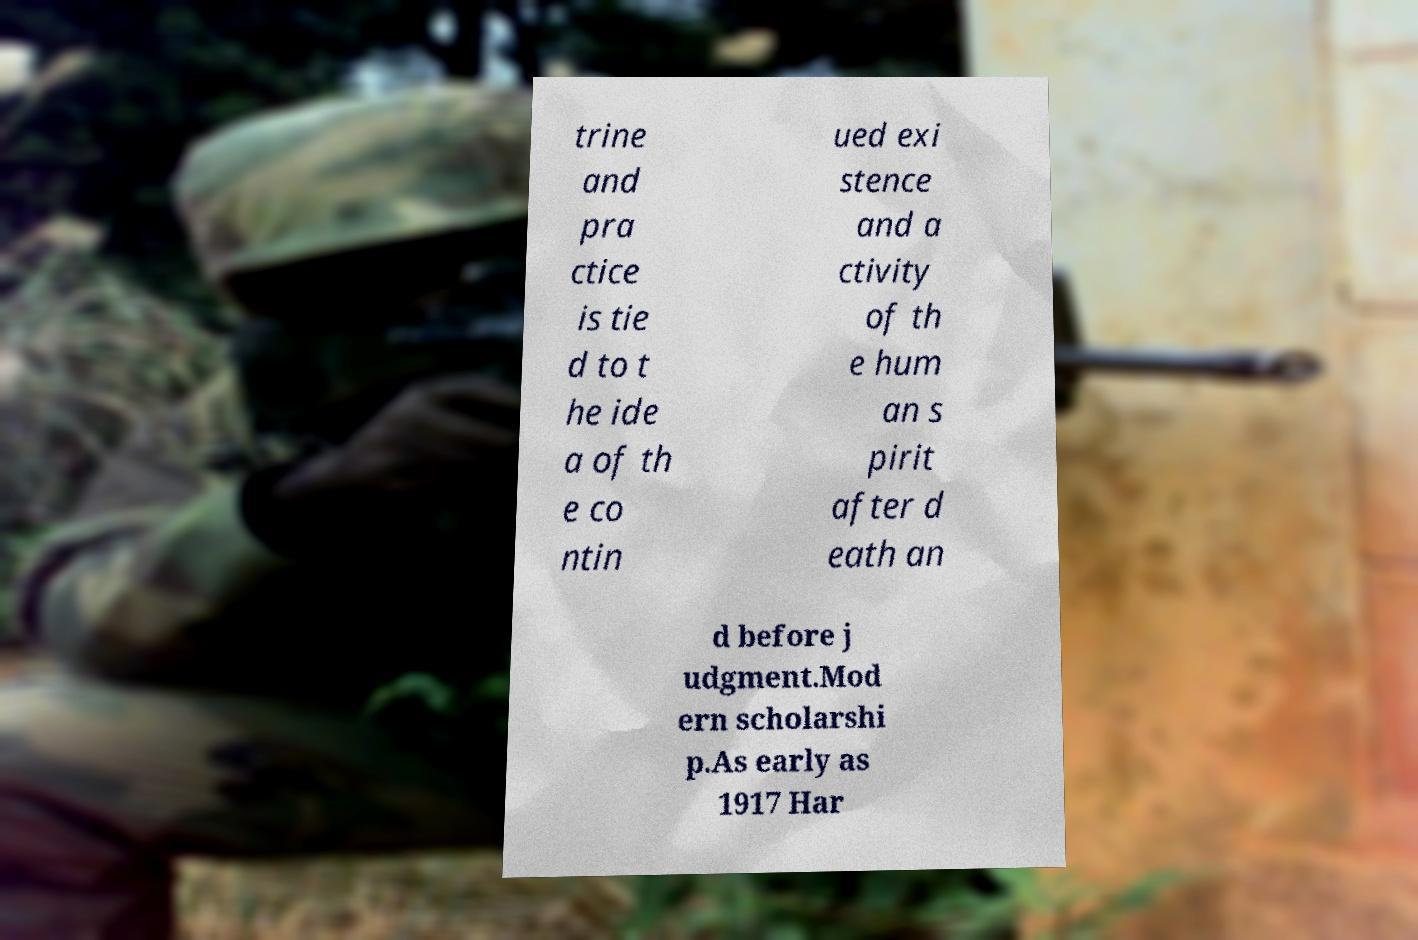What messages or text are displayed in this image? I need them in a readable, typed format. trine and pra ctice is tie d to t he ide a of th e co ntin ued exi stence and a ctivity of th e hum an s pirit after d eath an d before j udgment.Mod ern scholarshi p.As early as 1917 Har 